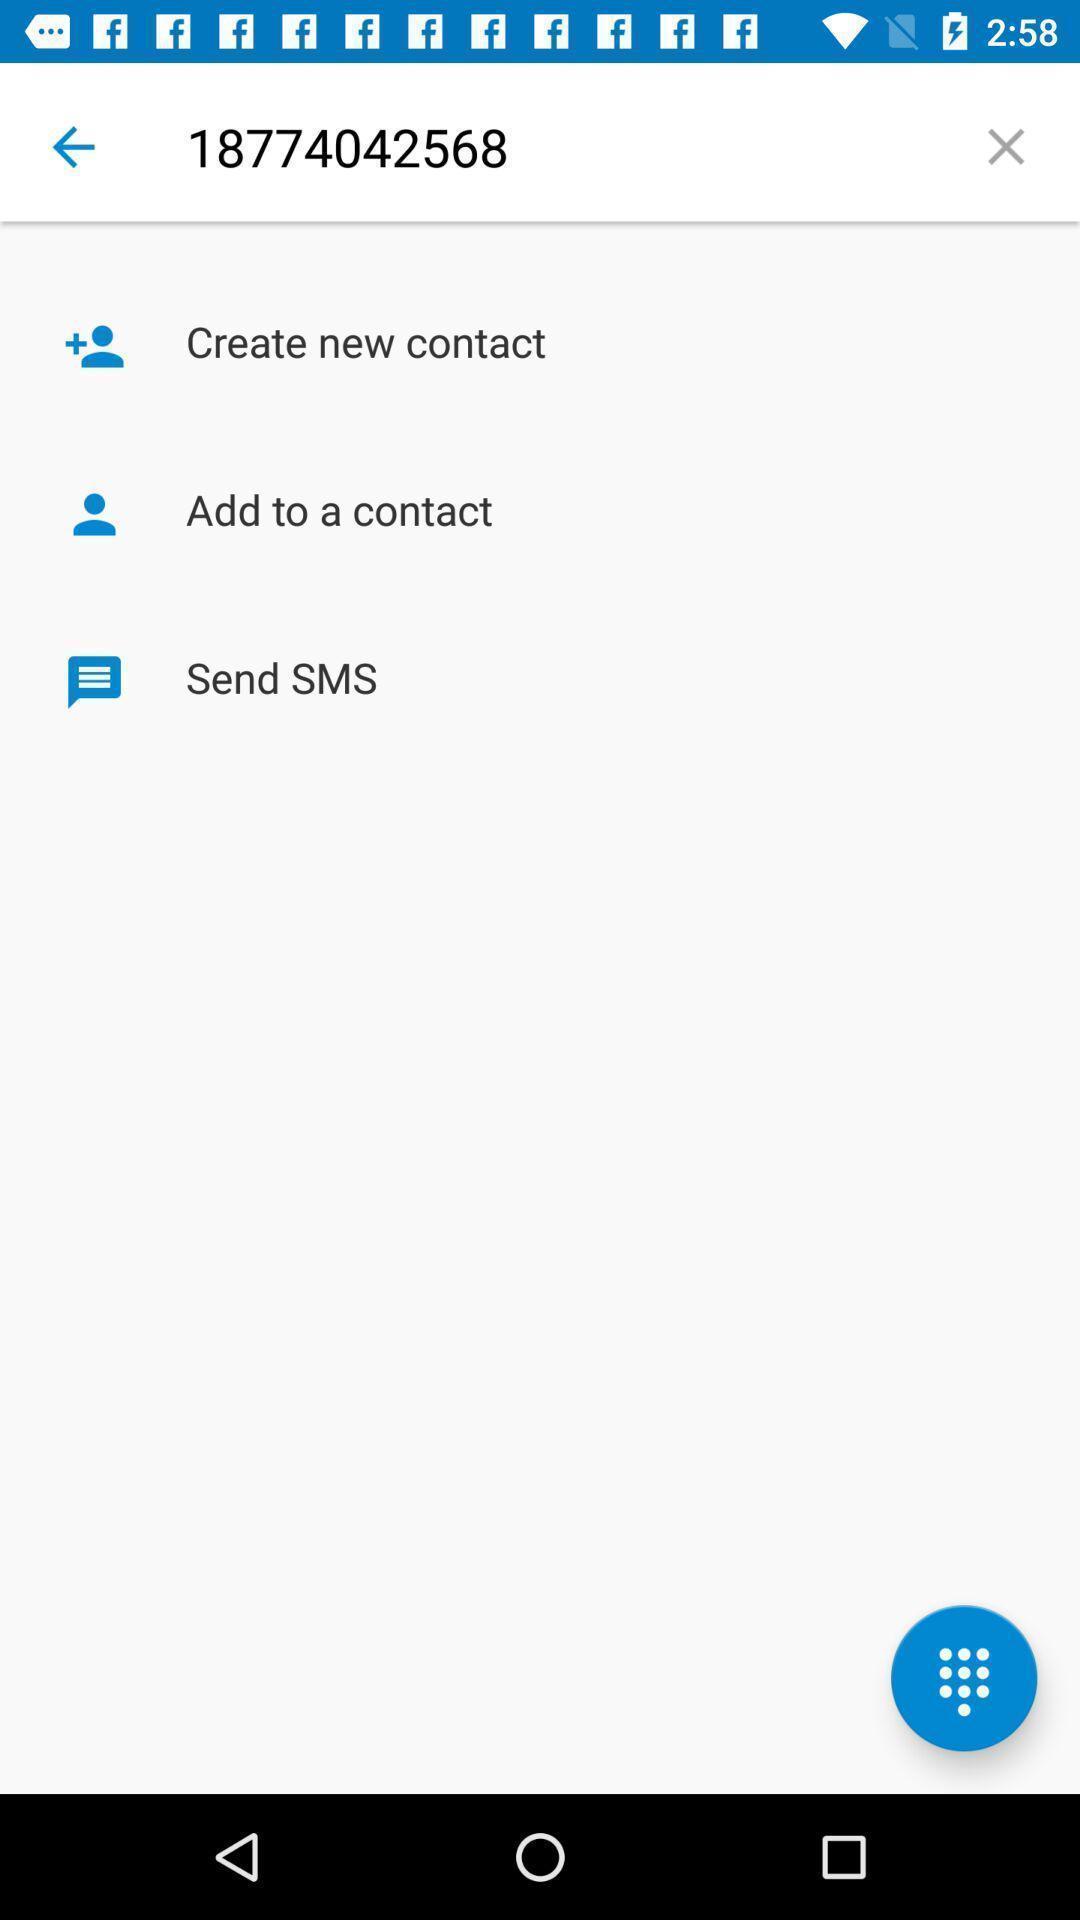Describe the visual elements of this screenshot. Screen displaying the contact number with options. 